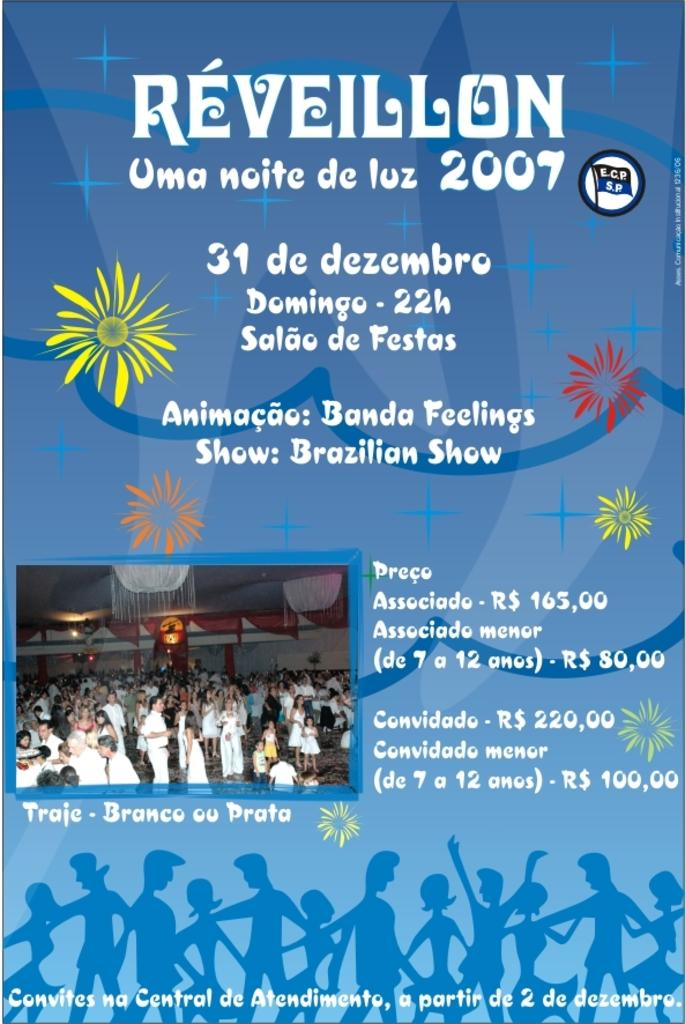<image>
Present a compact description of the photo's key features. A poster advertises Reveillon 2007 and includes an image of a crowd of people. 